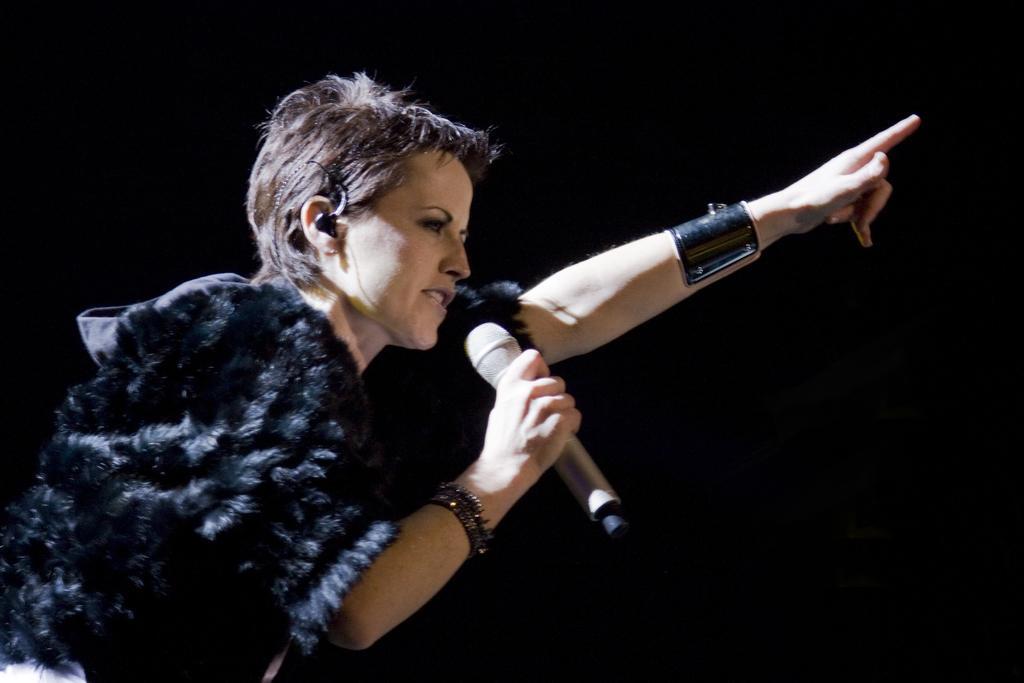Describe this image in one or two sentences. In this picture there is a girl on the left side of the image, by holding a mic in her hand. 